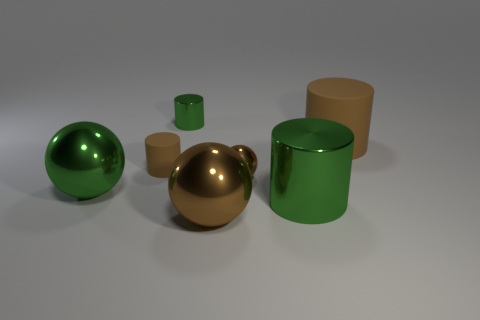Add 2 big brown spheres. How many objects exist? 9 Subtract all balls. How many objects are left? 4 Subtract 0 gray cylinders. How many objects are left? 7 Subtract all big brown cylinders. Subtract all tiny green shiny things. How many objects are left? 5 Add 3 balls. How many balls are left? 6 Add 1 green spheres. How many green spheres exist? 2 